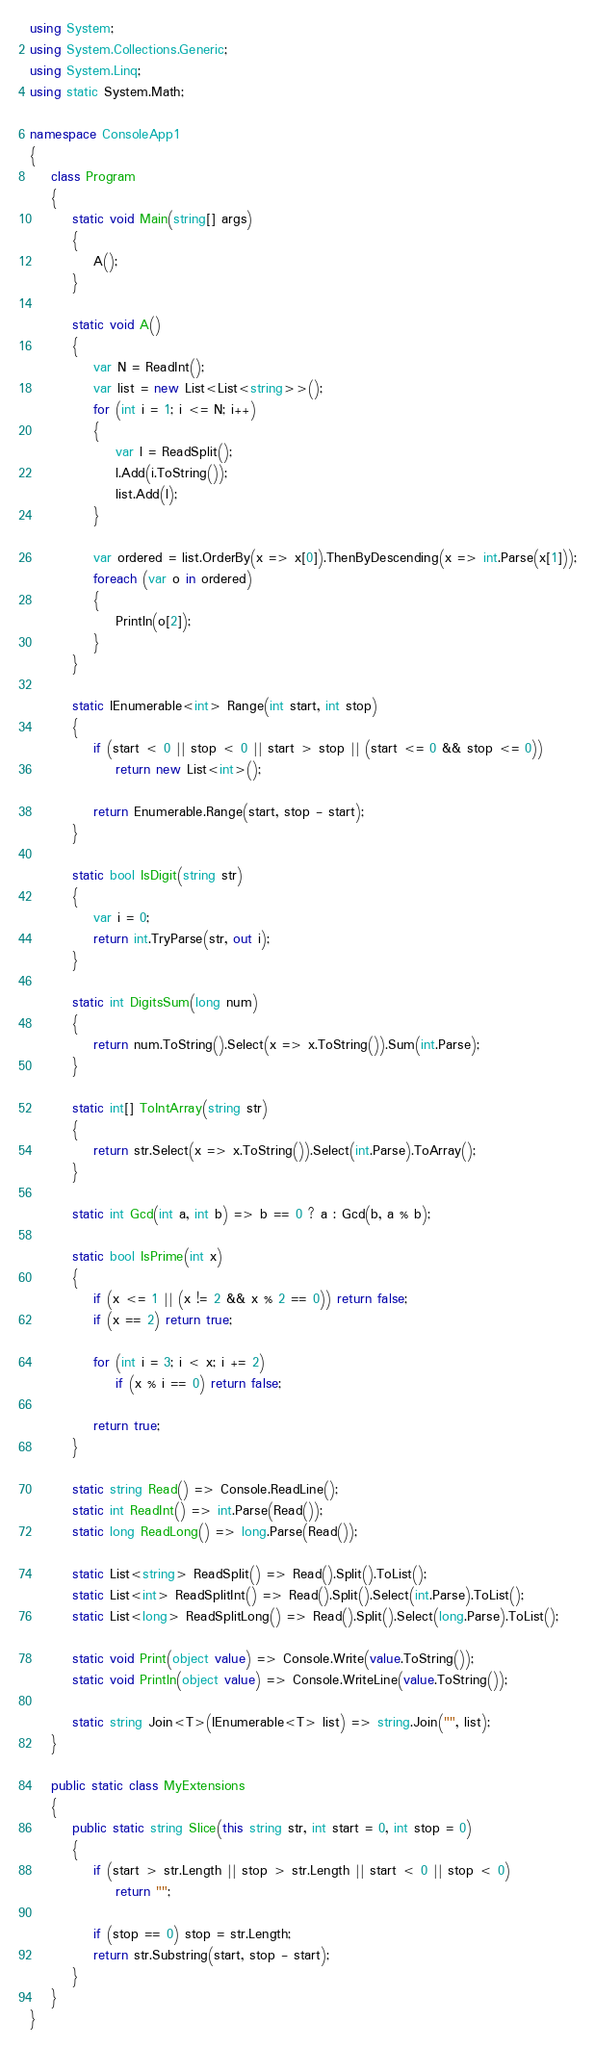Convert code to text. <code><loc_0><loc_0><loc_500><loc_500><_C#_>using System;
using System.Collections.Generic;
using System.Linq;
using static System.Math;

namespace ConsoleApp1
{
    class Program
    {
        static void Main(string[] args)
        {
            A();
        }

        static void A()
        {
            var N = ReadInt();
            var list = new List<List<string>>();
            for (int i = 1; i <= N; i++)
            {
                var l = ReadSplit();
                l.Add(i.ToString());
                list.Add(l);
            }

            var ordered = list.OrderBy(x => x[0]).ThenByDescending(x => int.Parse(x[1]));
            foreach (var o in ordered)
            {
                Println(o[2]);
            }
        }

        static IEnumerable<int> Range(int start, int stop)
        {
            if (start < 0 || stop < 0 || start > stop || (start <= 0 && stop <= 0))
                return new List<int>();

            return Enumerable.Range(start, stop - start);
        }

        static bool IsDigit(string str)
        {
            var i = 0;
            return int.TryParse(str, out i);
        }

        static int DigitsSum(long num)
        {
            return num.ToString().Select(x => x.ToString()).Sum(int.Parse);
        }

        static int[] ToIntArray(string str)
        {
            return str.Select(x => x.ToString()).Select(int.Parse).ToArray();
        }

        static int Gcd(int a, int b) => b == 0 ? a : Gcd(b, a % b);

        static bool IsPrime(int x)
        {
            if (x <= 1 || (x != 2 && x % 2 == 0)) return false;
            if (x == 2) return true;

            for (int i = 3; i < x; i += 2)
                if (x % i == 0) return false;

            return true;
        }

        static string Read() => Console.ReadLine();
        static int ReadInt() => int.Parse(Read());
        static long ReadLong() => long.Parse(Read());

        static List<string> ReadSplit() => Read().Split().ToList();
        static List<int> ReadSplitInt() => Read().Split().Select(int.Parse).ToList();
        static List<long> ReadSplitLong() => Read().Split().Select(long.Parse).ToList();

        static void Print(object value) => Console.Write(value.ToString());
        static void Println(object value) => Console.WriteLine(value.ToString());

        static string Join<T>(IEnumerable<T> list) => string.Join("", list);
    }

    public static class MyExtensions
    {
        public static string Slice(this string str, int start = 0, int stop = 0)
        {
            if (start > str.Length || stop > str.Length || start < 0 || stop < 0)
                return "";

            if (stop == 0) stop = str.Length;
            return str.Substring(start, stop - start);
        }
    }
}

</code> 